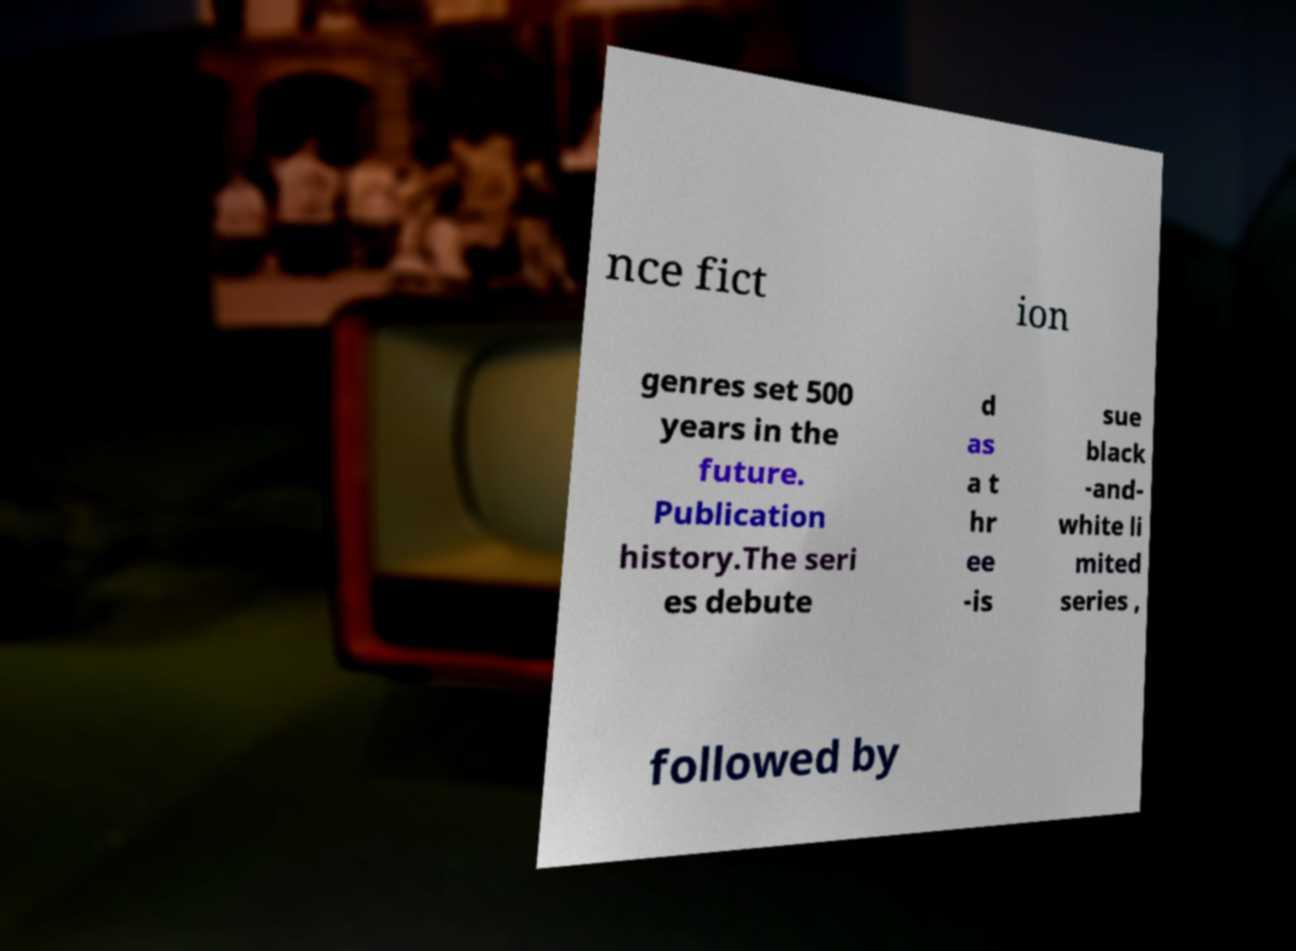For documentation purposes, I need the text within this image transcribed. Could you provide that? nce fict ion genres set 500 years in the future. Publication history.The seri es debute d as a t hr ee -is sue black -and- white li mited series , followed by 